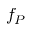Convert formula to latex. <formula><loc_0><loc_0><loc_500><loc_500>f _ { P }</formula> 